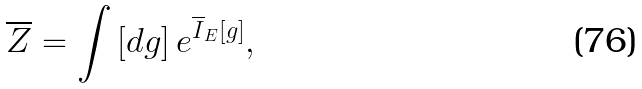<formula> <loc_0><loc_0><loc_500><loc_500>\overline { Z } = \int \left [ d g \right ] e ^ { \overline { I } _ { E } [ g ] } ,</formula> 